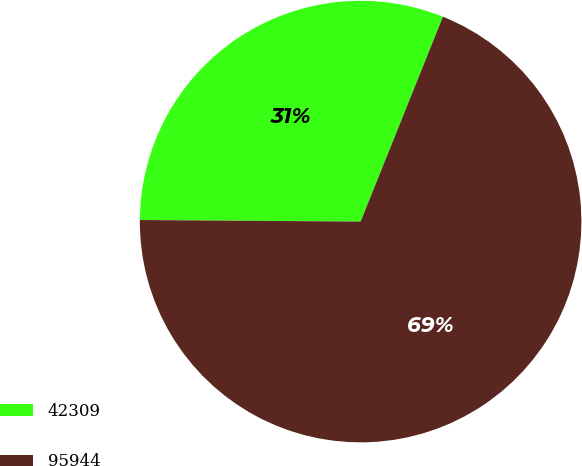Convert chart. <chart><loc_0><loc_0><loc_500><loc_500><pie_chart><fcel>42309<fcel>95944<nl><fcel>30.97%<fcel>69.03%<nl></chart> 